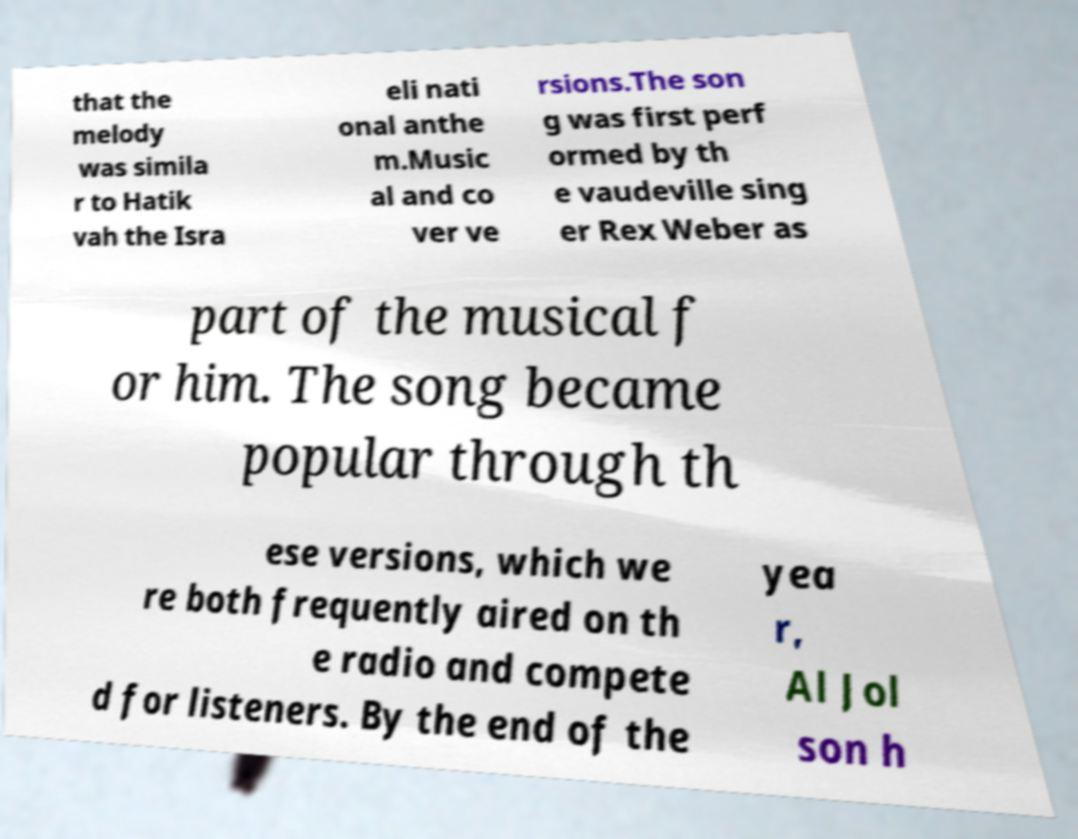Could you assist in decoding the text presented in this image and type it out clearly? that the melody was simila r to Hatik vah the Isra eli nati onal anthe m.Music al and co ver ve rsions.The son g was first perf ormed by th e vaudeville sing er Rex Weber as part of the musical f or him. The song became popular through th ese versions, which we re both frequently aired on th e radio and compete d for listeners. By the end of the yea r, Al Jol son h 